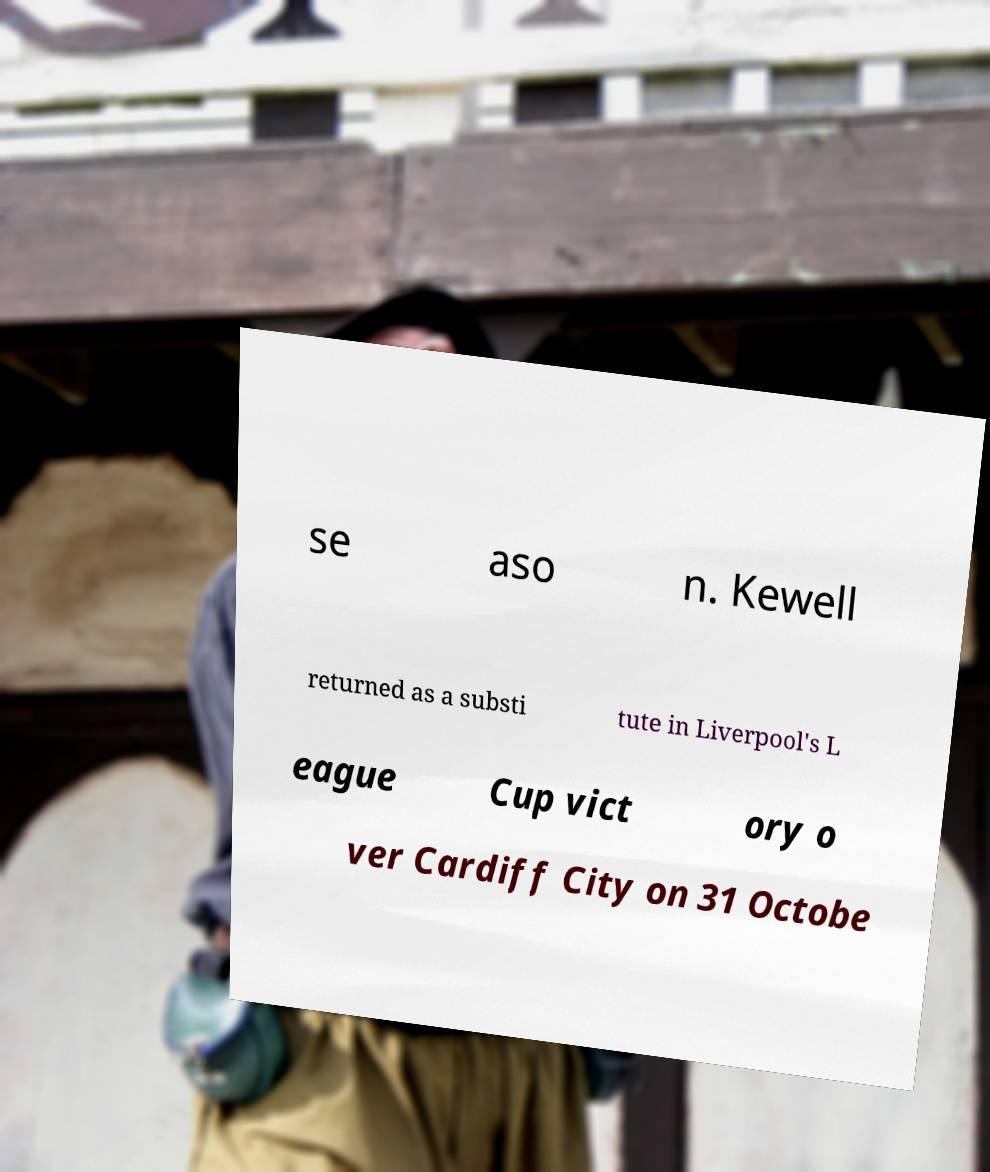Can you accurately transcribe the text from the provided image for me? se aso n. Kewell returned as a substi tute in Liverpool's L eague Cup vict ory o ver Cardiff City on 31 Octobe 